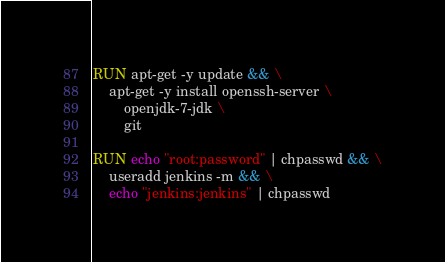<code> <loc_0><loc_0><loc_500><loc_500><_Dockerfile_>RUN apt-get -y update && \
    apt-get -y install openssh-server \
        openjdk-7-jdk \
        git

RUN echo "root:password" | chpasswd && \
    useradd jenkins -m && \
    echo "jenkins:jenkins" | chpasswd
</code> 